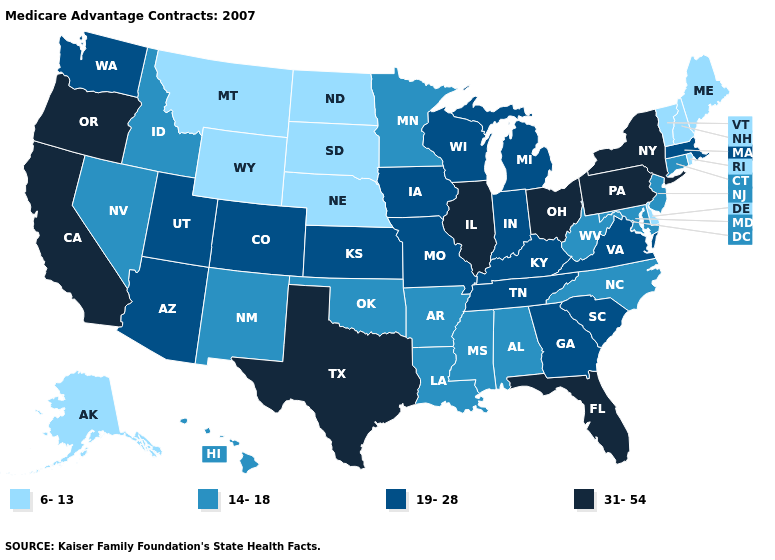Name the states that have a value in the range 14-18?
Write a very short answer. Alabama, Arkansas, Connecticut, Hawaii, Idaho, Louisiana, Maryland, Minnesota, Mississippi, North Carolina, New Jersey, New Mexico, Nevada, Oklahoma, West Virginia. Name the states that have a value in the range 6-13?
Give a very brief answer. Alaska, Delaware, Maine, Montana, North Dakota, Nebraska, New Hampshire, Rhode Island, South Dakota, Vermont, Wyoming. Name the states that have a value in the range 19-28?
Keep it brief. Arizona, Colorado, Georgia, Iowa, Indiana, Kansas, Kentucky, Massachusetts, Michigan, Missouri, South Carolina, Tennessee, Utah, Virginia, Washington, Wisconsin. Does Missouri have a lower value than South Carolina?
Concise answer only. No. What is the value of Tennessee?
Concise answer only. 19-28. What is the value of Colorado?
Give a very brief answer. 19-28. Name the states that have a value in the range 19-28?
Answer briefly. Arizona, Colorado, Georgia, Iowa, Indiana, Kansas, Kentucky, Massachusetts, Michigan, Missouri, South Carolina, Tennessee, Utah, Virginia, Washington, Wisconsin. What is the highest value in the USA?
Write a very short answer. 31-54. Is the legend a continuous bar?
Concise answer only. No. Name the states that have a value in the range 19-28?
Short answer required. Arizona, Colorado, Georgia, Iowa, Indiana, Kansas, Kentucky, Massachusetts, Michigan, Missouri, South Carolina, Tennessee, Utah, Virginia, Washington, Wisconsin. Name the states that have a value in the range 19-28?
Answer briefly. Arizona, Colorado, Georgia, Iowa, Indiana, Kansas, Kentucky, Massachusetts, Michigan, Missouri, South Carolina, Tennessee, Utah, Virginia, Washington, Wisconsin. What is the highest value in states that border Georgia?
Short answer required. 31-54. Does Pennsylvania have the highest value in the Northeast?
Give a very brief answer. Yes. Name the states that have a value in the range 31-54?
Answer briefly. California, Florida, Illinois, New York, Ohio, Oregon, Pennsylvania, Texas. Name the states that have a value in the range 31-54?
Be succinct. California, Florida, Illinois, New York, Ohio, Oregon, Pennsylvania, Texas. 